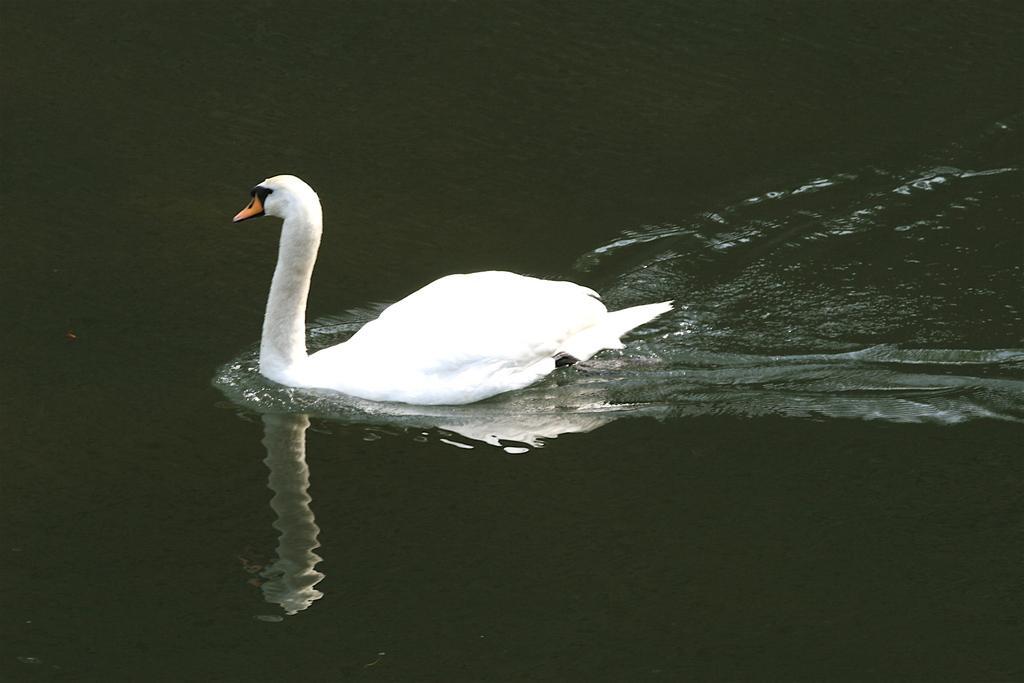How would you summarize this image in a sentence or two? There is a white color bird, swimming on the water. In which, there is a mirror image of it. And the background is dark in color. 